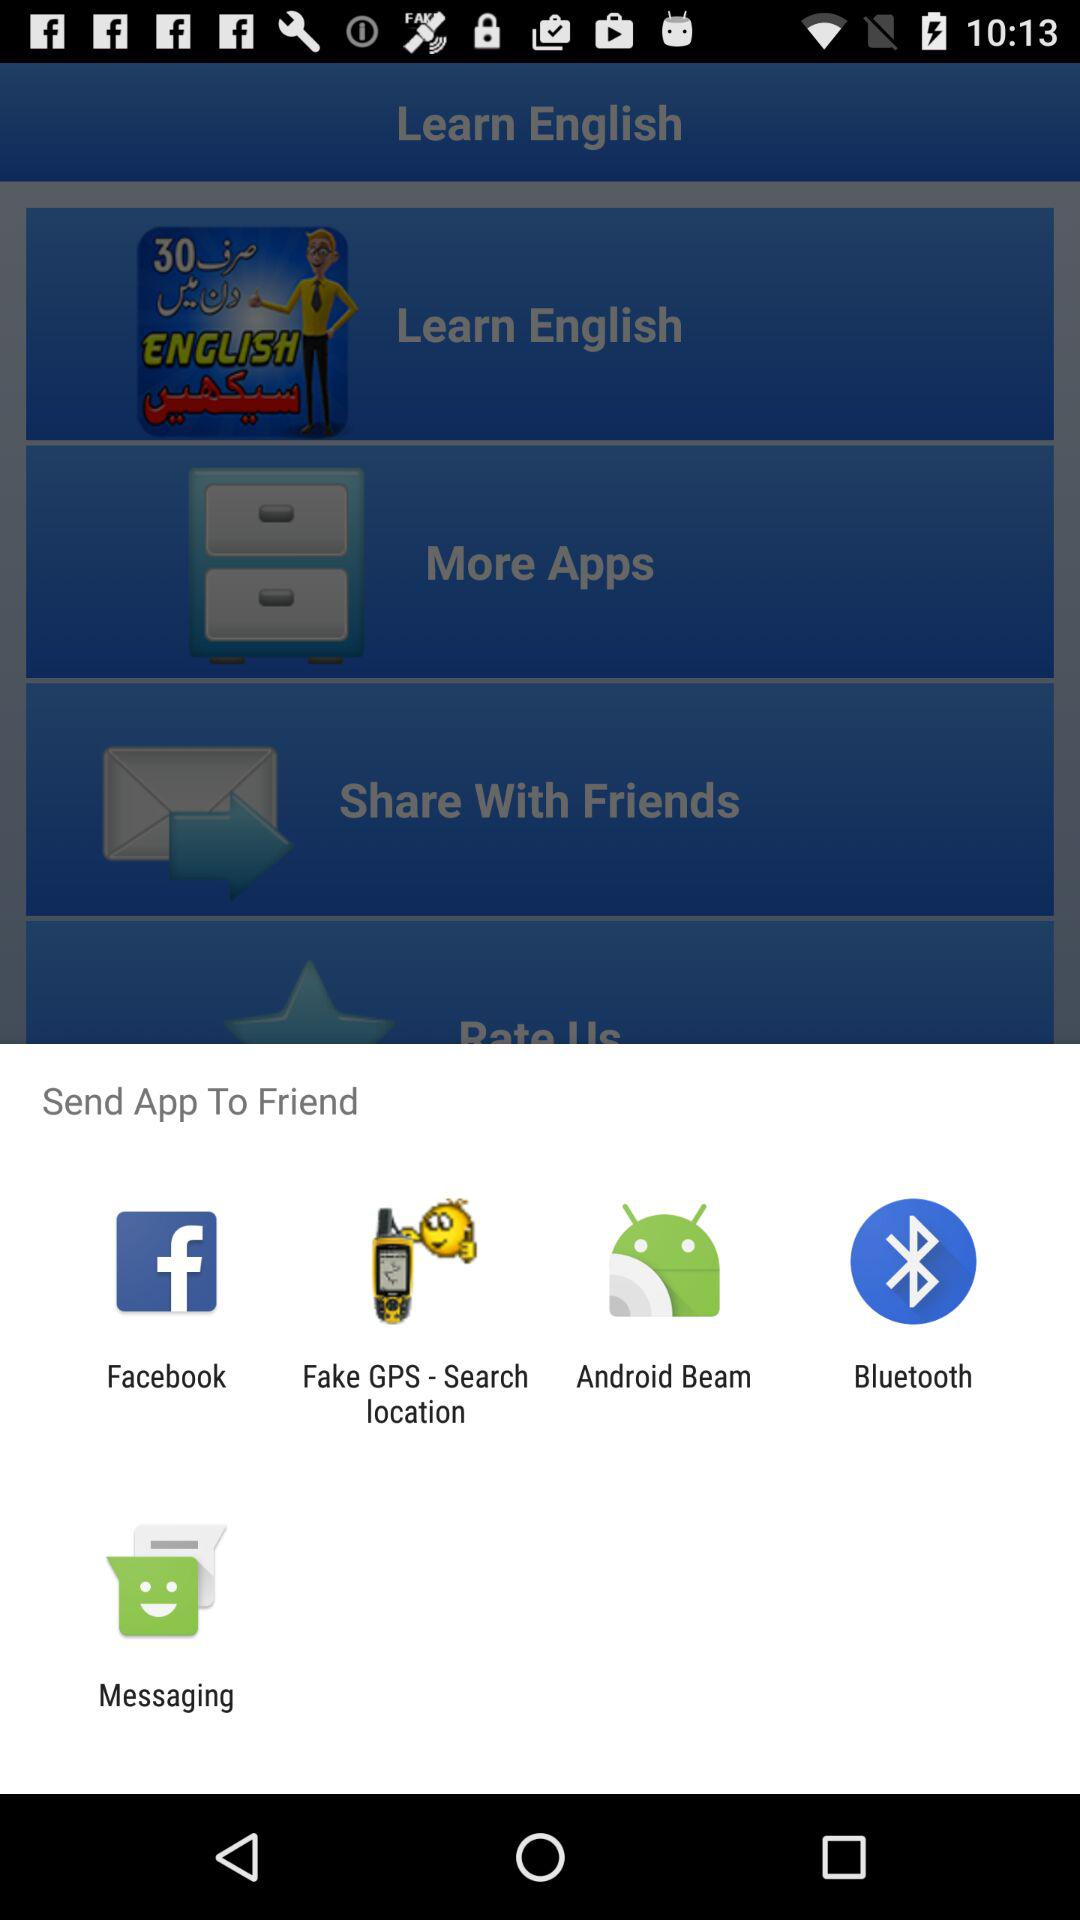Through which application can we send the app to a friend? You can send the app to a friend through "Facebook", "Fake GPS - Search location", "Android Beam", "Bluetooth" and "Messaging". 